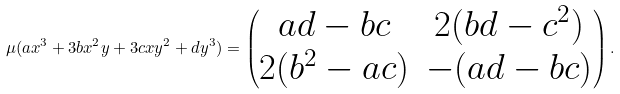<formula> <loc_0><loc_0><loc_500><loc_500>\mu ( a x ^ { 3 } + 3 b x ^ { 2 } y + 3 c x y ^ { 2 } + d y ^ { 3 } ) = \begin{pmatrix} a d - b c & 2 ( b d - c ^ { 2 } ) \\ 2 ( b ^ { 2 } - a c ) & - ( a d - b c ) \end{pmatrix} .</formula> 